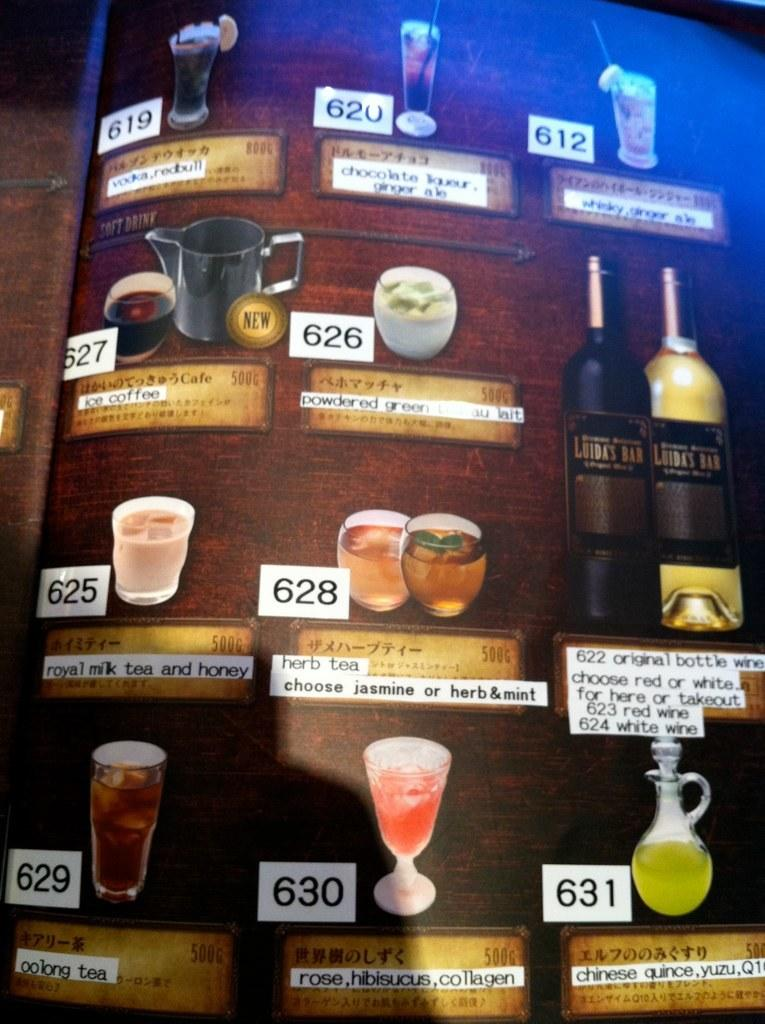<image>
Provide a brief description of the given image. Menu that has a number next to a drink that says 630. 